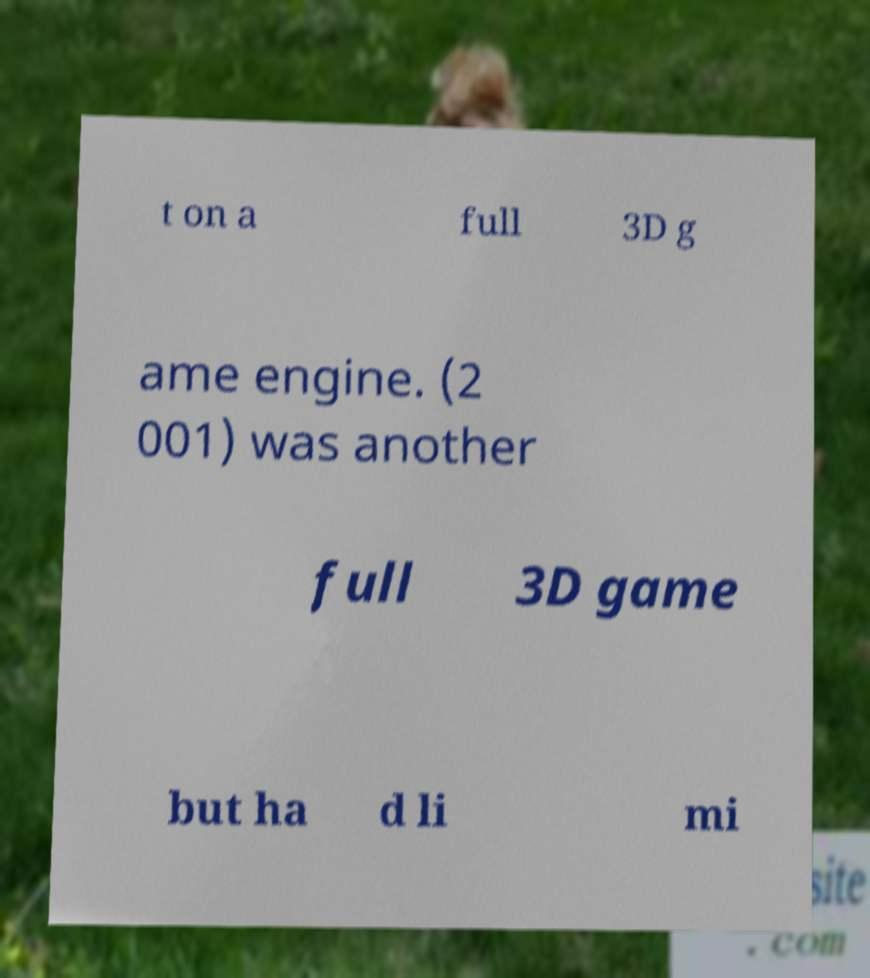I need the written content from this picture converted into text. Can you do that? t on a full 3D g ame engine. (2 001) was another full 3D game but ha d li mi 